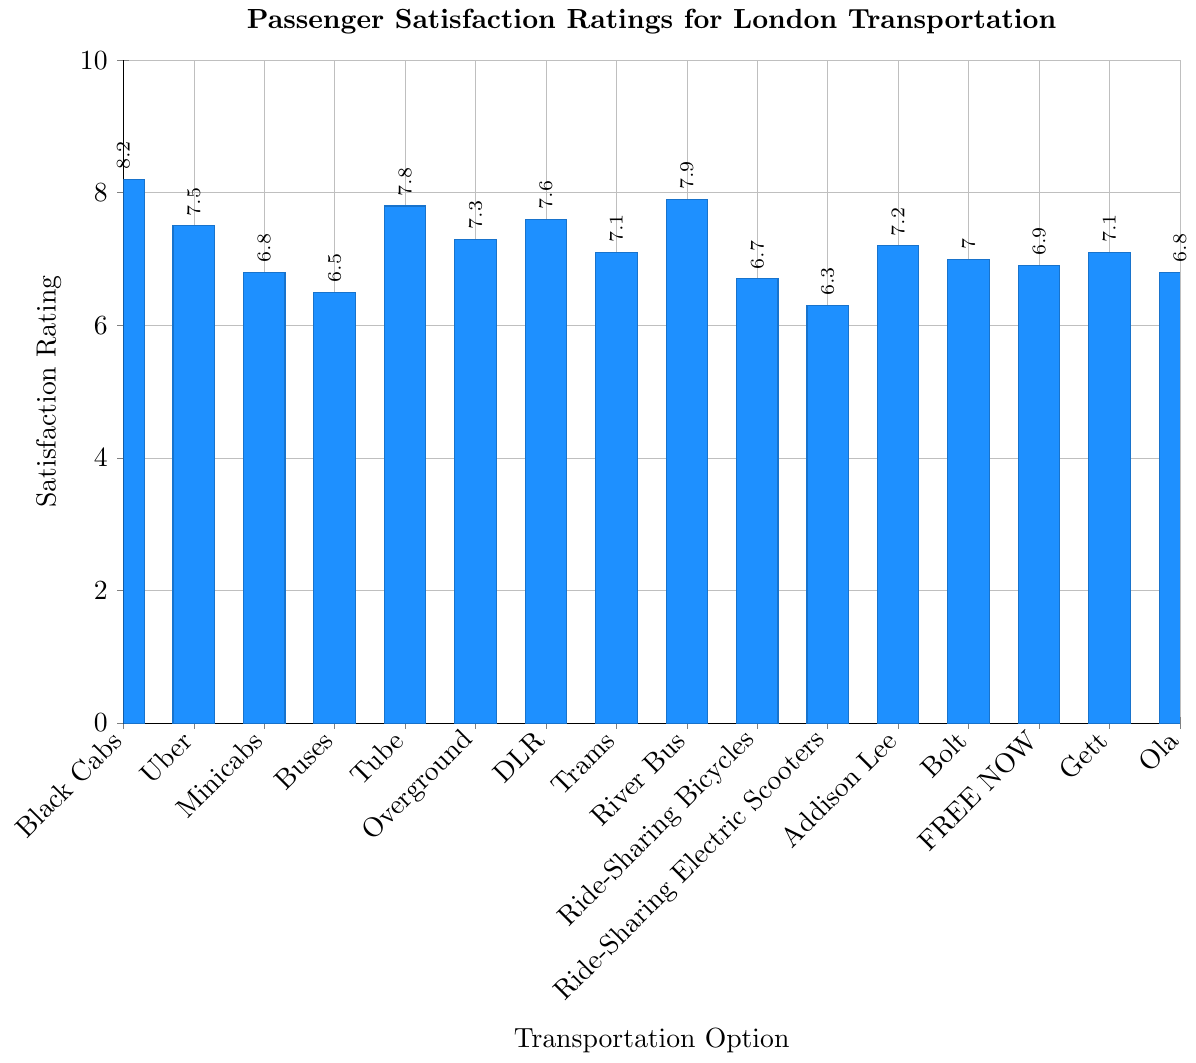Which transportation option has the highest satisfaction rating? The bar for "Black Cabs" is the tallest on the graph with a height corresponding to a rating of 8.2.
Answer: Black Cabs Which transportation option has the lowest satisfaction rating? The bar for "Ride-Sharing Electric Scooters" is the shortest on the graph with a height corresponding to a rating of 6.3.
Answer: Ride-Sharing Electric Scooters How much higher is the satisfaction rating of Black Cabs compared to Uber? The rating for Black Cabs is 8.2 and for Uber is 7.5. Subtracting these gives 8.2 - 7.5 = 0.7.
Answer: 0.7 What is the average satisfaction rating for transportation options provided exclusively by companies (Black Cabs, Uber, Minicabs, Addison Lee, Bolt, FREE NOW, Gett, Ola)? The ratings are: Black Cabs (8.2), Uber (7.5), Minicabs (6.8), Addison Lee (7.2), Bolt (7.0), FREE NOW (6.9), Gett (7.1), Ola (6.8). Sum these up: 8.2 + 7.5 + 6.8 + 7.2 + 7.0 + 6.9 + 7.1 + 6.8 = 57.5. There are 8 options, so the average is 57.5 / 8 = 7.1875.
Answer: 7.19 Are buses rated higher than tube? The rating for Buses is 6.5 and for Tube is 7.8, making buses rated lower than tube.
Answer: No Which options have a satisfaction rating above 7? By observing the bar heights, the options are Black Cabs (8.2), Uber (7.5), Tube (7.8), DLR (7.6), River Bus (7.9), Overground (7.3), Addison Lee (7.2), Gett (7.1).
Answer: Black Cabs, Uber, Tube, DLR, River Bus, Overground, Addison Lee, Gett What is the difference in satisfaction rating between the highest and lowest rated options? The highest rating is for Black Cabs (8.2) and the lowest is for Ride-Sharing Electric Scooters (6.3). Subtracting these gives 8.2 - 6.3 = 1.9.
Answer: 1.9 Is the satisfaction rating for Bolt higher than for Minicabs? The rating for Bolt is 7.0 and for Minicabs is 6.8, making Bolt rated higher.
Answer: Yes Which transportation option has a satisfaction rating closest to 7? Reviewing the bars, the ratings for Addison Lee (7.2), Overground (7.3), DLR (7.6), and Bolt (7.0) are close to 7. Bolt has the closest rating at exactly 7.0.
Answer: Bolt Of the ride-sharing services (Uber, Addison Lee, Bolt, FREE NOW, Gett, Ola), which has the highest satisfaction rating? Reviewing the bars, Uber has a rating of 7.5 which is higher than Addison Lee (7.2), Bolt (7.0), FREE NOW (6.9), Gett (7.1), and Ola (6.8).
Answer: Uber 